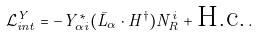<formula> <loc_0><loc_0><loc_500><loc_500>\mathcal { L } _ { i n t } ^ { Y } = - Y ^ { * } _ { \alpha i } ( \bar { L } _ { \alpha } \cdot H ^ { \dagger } ) N _ { R } ^ { i } + \text {H.c.} \, .</formula> 